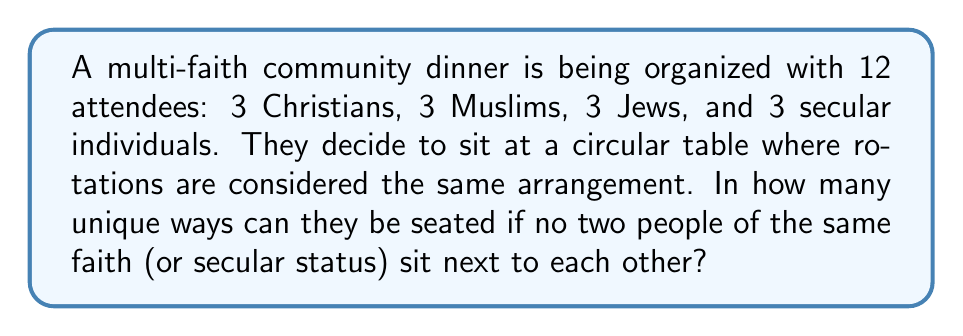Help me with this question. Let's approach this step-by-step:

1) First, we need to arrange the different faiths. This is equivalent to arranging 4 distinct items in a circle. The number of ways to do this is $(4-1)! = 3! = 6$.

2) Now, for each of these 6 arrangements of faiths, we need to arrange the individuals within each faith group.

3) For each faith group (and the secular group), we have 3! = 6 ways to arrange the 3 individuals.

4) By the multiplication principle, the total number of arrangements is:

   $$6 \cdot 6 \cdot 6 \cdot 6 \cdot 6 = 6^5 = 7776$$

5) However, we're considering rotations as the same arrangement. In a circular arrangement with 12 people, each unique arrangement is counted 12 times (once for each possible starting point).

6) Therefore, we need to divide our total by 12:

   $$\frac{7776}{12} = 648$$

Thus, there are 648 unique seating arrangements.
Answer: 648 